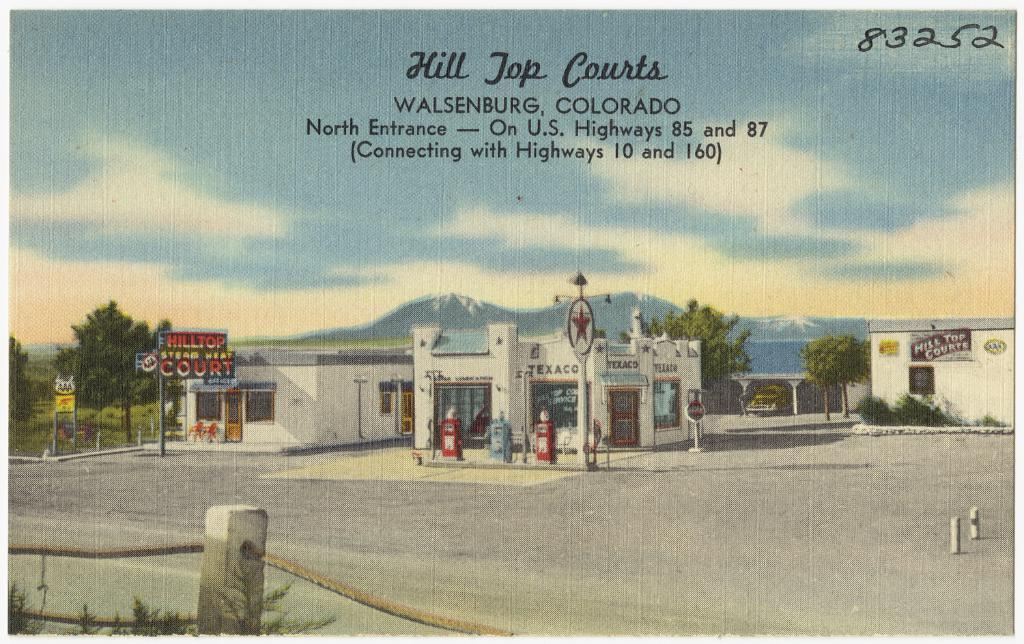What can be seen in the center of the image? There are buildings and trees in the center of the image. What is located at the bottom of the image? There is a fence at the bottom of the image. What is visible in the background of the image? There is a hill and the sky visible in the background of the image. Is there any text present in the image? Yes, there is a text in the image. How many owls are sitting on the fence in the image? There are no owls present in the image. Is there a river flowing through the buildings in the image? There is no river visible in the image. 